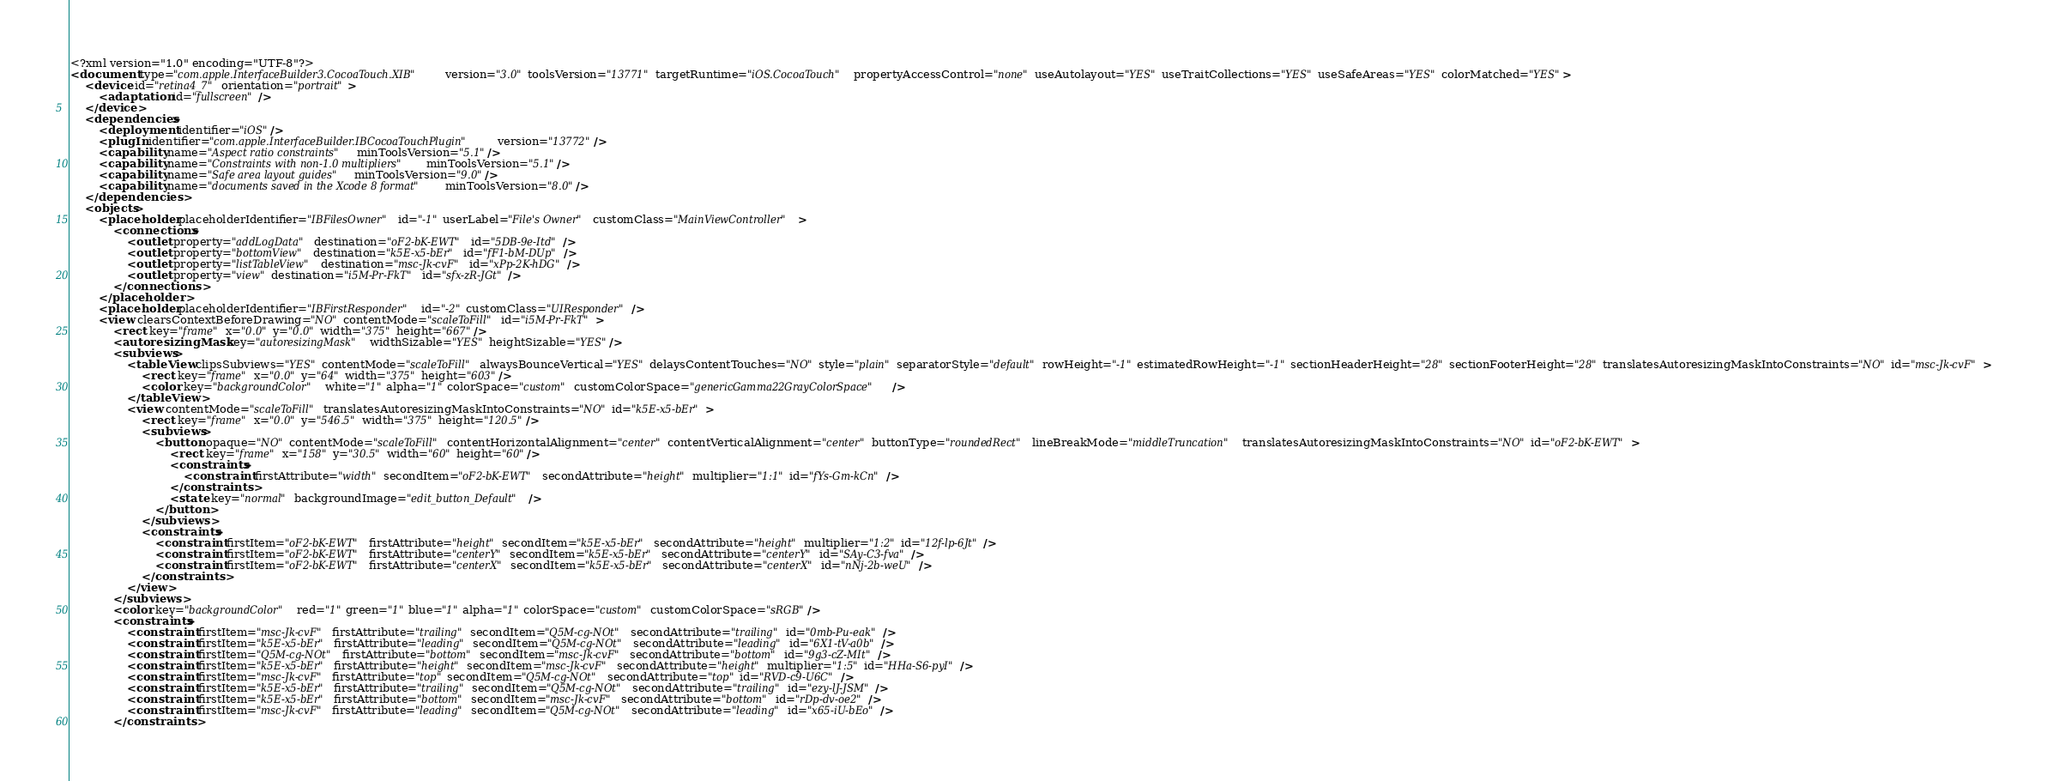Convert code to text. <code><loc_0><loc_0><loc_500><loc_500><_XML_><?xml version="1.0" encoding="UTF-8"?>
<document type="com.apple.InterfaceBuilder3.CocoaTouch.XIB" version="3.0" toolsVersion="13771" targetRuntime="iOS.CocoaTouch" propertyAccessControl="none" useAutolayout="YES" useTraitCollections="YES" useSafeAreas="YES" colorMatched="YES">
    <device id="retina4_7" orientation="portrait">
        <adaptation id="fullscreen"/>
    </device>
    <dependencies>
        <deployment identifier="iOS"/>
        <plugIn identifier="com.apple.InterfaceBuilder.IBCocoaTouchPlugin" version="13772"/>
        <capability name="Aspect ratio constraints" minToolsVersion="5.1"/>
        <capability name="Constraints with non-1.0 multipliers" minToolsVersion="5.1"/>
        <capability name="Safe area layout guides" minToolsVersion="9.0"/>
        <capability name="documents saved in the Xcode 8 format" minToolsVersion="8.0"/>
    </dependencies>
    <objects>
        <placeholder placeholderIdentifier="IBFilesOwner" id="-1" userLabel="File's Owner" customClass="MainViewController">
            <connections>
                <outlet property="addLogData" destination="oF2-bK-EWT" id="5DB-9e-Itd"/>
                <outlet property="bottomView" destination="k5E-x5-bEr" id="fF1-bM-DUp"/>
                <outlet property="listTableView" destination="msc-Jk-cvF" id="xPp-2K-hDG"/>
                <outlet property="view" destination="i5M-Pr-FkT" id="sfx-zR-JGt"/>
            </connections>
        </placeholder>
        <placeholder placeholderIdentifier="IBFirstResponder" id="-2" customClass="UIResponder"/>
        <view clearsContextBeforeDrawing="NO" contentMode="scaleToFill" id="i5M-Pr-FkT">
            <rect key="frame" x="0.0" y="0.0" width="375" height="667"/>
            <autoresizingMask key="autoresizingMask" widthSizable="YES" heightSizable="YES"/>
            <subviews>
                <tableView clipsSubviews="YES" contentMode="scaleToFill" alwaysBounceVertical="YES" delaysContentTouches="NO" style="plain" separatorStyle="default" rowHeight="-1" estimatedRowHeight="-1" sectionHeaderHeight="28" sectionFooterHeight="28" translatesAutoresizingMaskIntoConstraints="NO" id="msc-Jk-cvF">
                    <rect key="frame" x="0.0" y="64" width="375" height="603"/>
                    <color key="backgroundColor" white="1" alpha="1" colorSpace="custom" customColorSpace="genericGamma22GrayColorSpace"/>
                </tableView>
                <view contentMode="scaleToFill" translatesAutoresizingMaskIntoConstraints="NO" id="k5E-x5-bEr">
                    <rect key="frame" x="0.0" y="546.5" width="375" height="120.5"/>
                    <subviews>
                        <button opaque="NO" contentMode="scaleToFill" contentHorizontalAlignment="center" contentVerticalAlignment="center" buttonType="roundedRect" lineBreakMode="middleTruncation" translatesAutoresizingMaskIntoConstraints="NO" id="oF2-bK-EWT">
                            <rect key="frame" x="158" y="30.5" width="60" height="60"/>
                            <constraints>
                                <constraint firstAttribute="width" secondItem="oF2-bK-EWT" secondAttribute="height" multiplier="1:1" id="fYs-Gm-kCn"/>
                            </constraints>
                            <state key="normal" backgroundImage="edit_button_Default"/>
                        </button>
                    </subviews>
                    <constraints>
                        <constraint firstItem="oF2-bK-EWT" firstAttribute="height" secondItem="k5E-x5-bEr" secondAttribute="height" multiplier="1:2" id="12f-lp-6Jt"/>
                        <constraint firstItem="oF2-bK-EWT" firstAttribute="centerY" secondItem="k5E-x5-bEr" secondAttribute="centerY" id="SAy-C3-fva"/>
                        <constraint firstItem="oF2-bK-EWT" firstAttribute="centerX" secondItem="k5E-x5-bEr" secondAttribute="centerX" id="nNj-2b-weU"/>
                    </constraints>
                </view>
            </subviews>
            <color key="backgroundColor" red="1" green="1" blue="1" alpha="1" colorSpace="custom" customColorSpace="sRGB"/>
            <constraints>
                <constraint firstItem="msc-Jk-cvF" firstAttribute="trailing" secondItem="Q5M-cg-NOt" secondAttribute="trailing" id="0mb-Pu-eak"/>
                <constraint firstItem="k5E-x5-bEr" firstAttribute="leading" secondItem="Q5M-cg-NOt" secondAttribute="leading" id="6X1-tV-a0b"/>
                <constraint firstItem="Q5M-cg-NOt" firstAttribute="bottom" secondItem="msc-Jk-cvF" secondAttribute="bottom" id="9g3-cZ-MIt"/>
                <constraint firstItem="k5E-x5-bEr" firstAttribute="height" secondItem="msc-Jk-cvF" secondAttribute="height" multiplier="1:5" id="HHa-S6-pyI"/>
                <constraint firstItem="msc-Jk-cvF" firstAttribute="top" secondItem="Q5M-cg-NOt" secondAttribute="top" id="RVD-c9-U6C"/>
                <constraint firstItem="k5E-x5-bEr" firstAttribute="trailing" secondItem="Q5M-cg-NOt" secondAttribute="trailing" id="ezy-lJ-JSM"/>
                <constraint firstItem="k5E-x5-bEr" firstAttribute="bottom" secondItem="msc-Jk-cvF" secondAttribute="bottom" id="rDp-dv-oe2"/>
                <constraint firstItem="msc-Jk-cvF" firstAttribute="leading" secondItem="Q5M-cg-NOt" secondAttribute="leading" id="x65-iU-bEo"/>
            </constraints></code> 